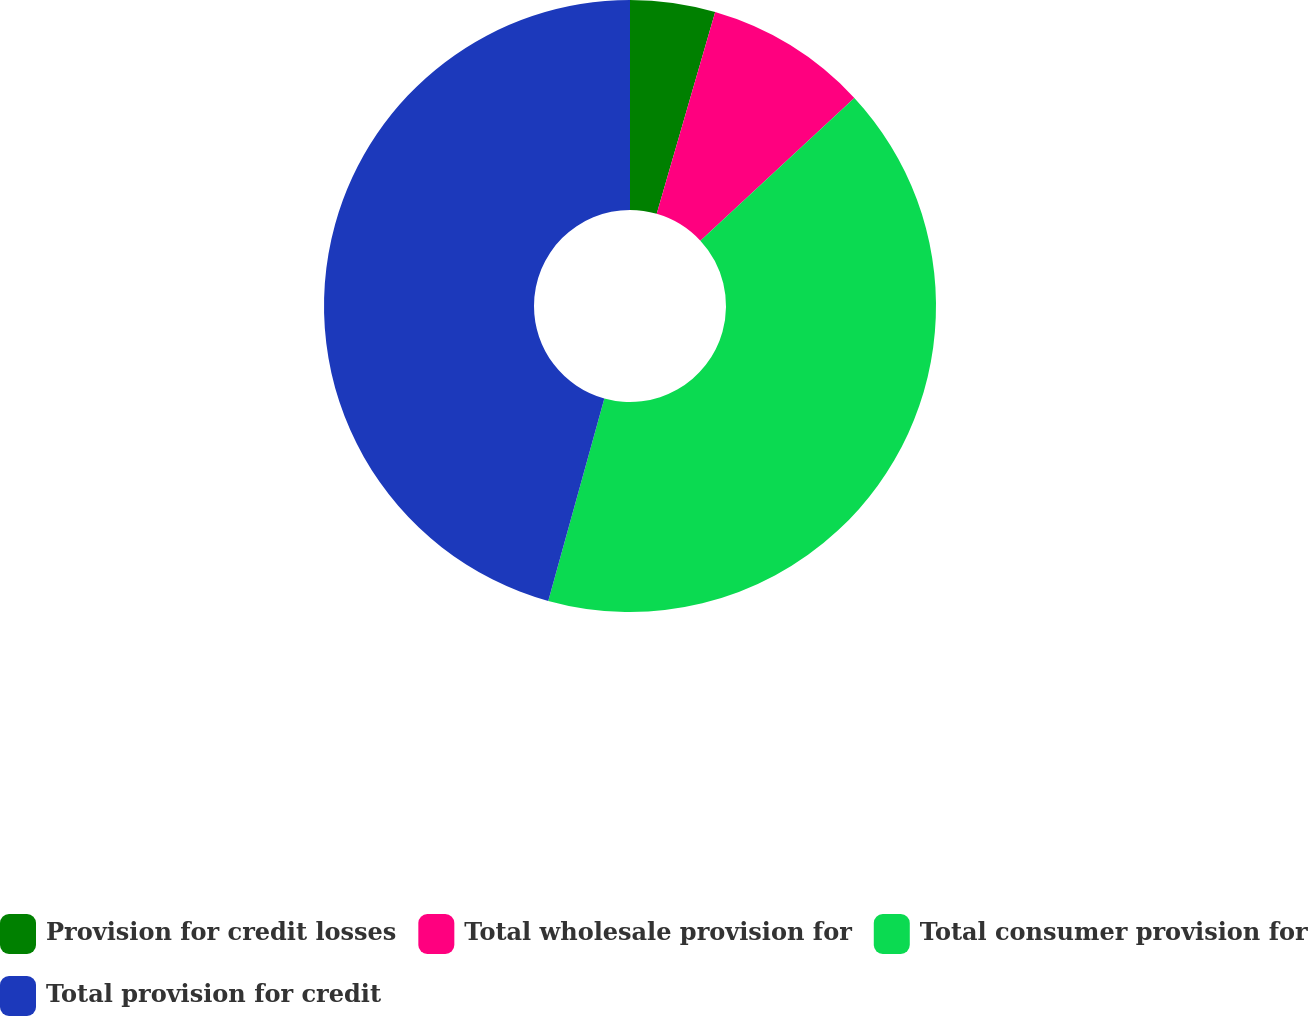Convert chart to OTSL. <chart><loc_0><loc_0><loc_500><loc_500><pie_chart><fcel>Provision for credit losses<fcel>Total wholesale provision for<fcel>Total consumer provision for<fcel>Total provision for credit<nl><fcel>4.49%<fcel>8.61%<fcel>41.21%<fcel>45.7%<nl></chart> 